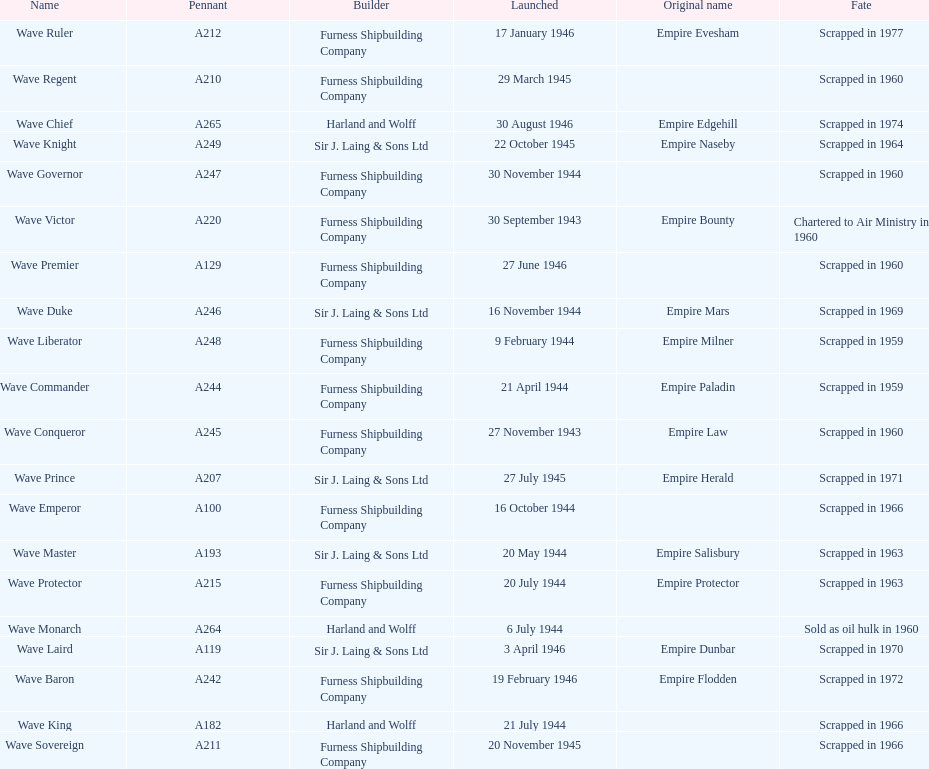Which other ship was launched in the same year as the wave victor? Wave Conqueror. 